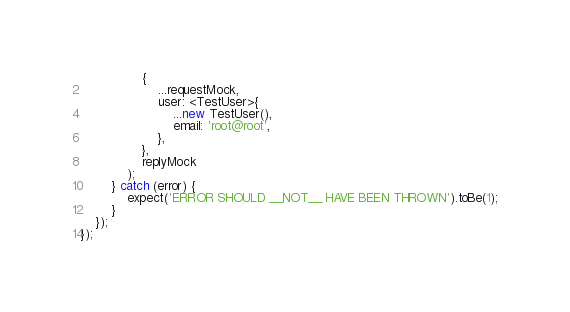Convert code to text. <code><loc_0><loc_0><loc_500><loc_500><_TypeScript_>                {
                    ...requestMock,
                    user: <TestUser>{
                        ...new TestUser(),
                        email: 'root@root',
                    },
                },
                replyMock
            );
        } catch (error) {
            expect('ERROR SHOULD __NOT__ HAVE BEEN THROWN').toBe(1);
        }
    });
});
</code> 